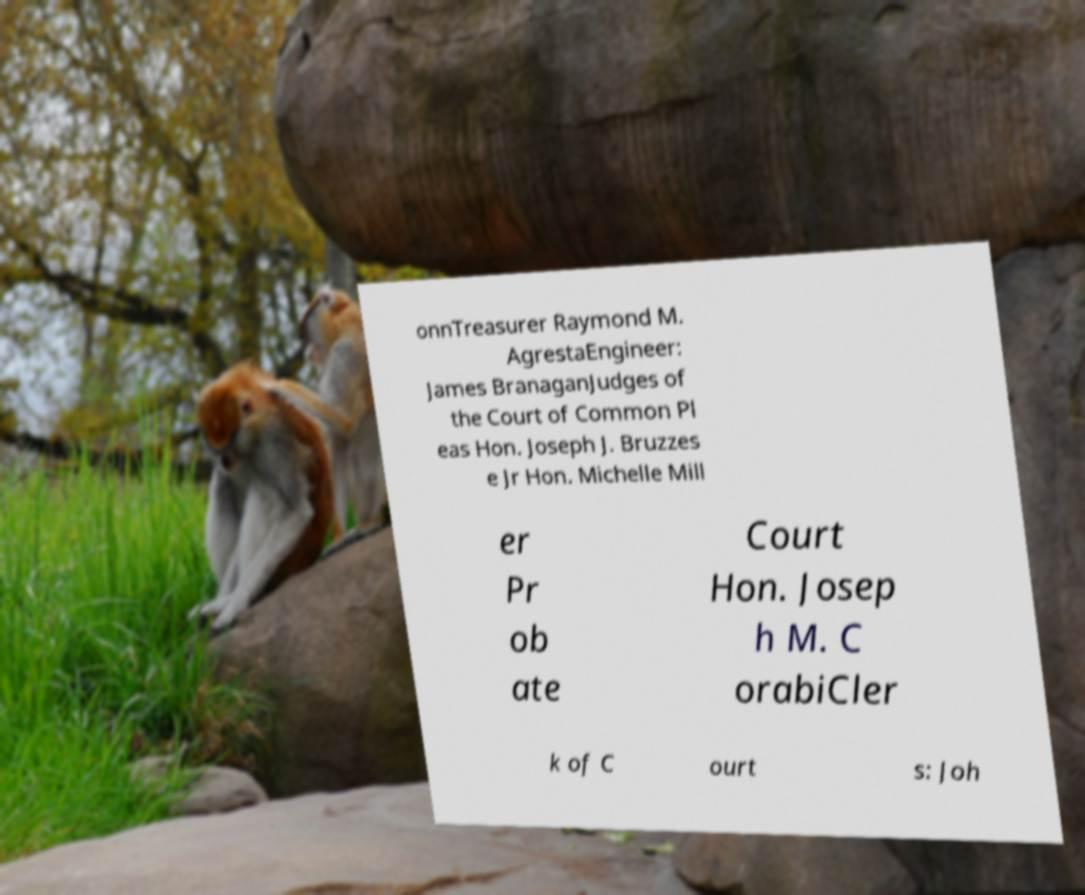Can you read and provide the text displayed in the image?This photo seems to have some interesting text. Can you extract and type it out for me? onnTreasurer Raymond M. AgrestaEngineer: James BranaganJudges of the Court of Common Pl eas Hon. Joseph J. Bruzzes e Jr Hon. Michelle Mill er Pr ob ate Court Hon. Josep h M. C orabiCler k of C ourt s: Joh 